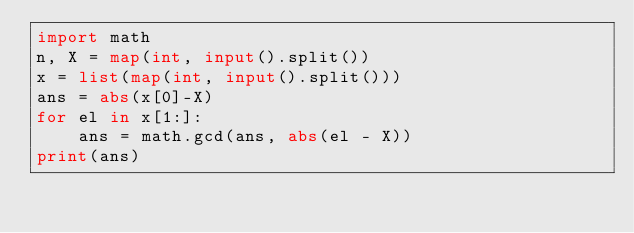<code> <loc_0><loc_0><loc_500><loc_500><_Python_>import math
n, X = map(int, input().split())
x = list(map(int, input().split()))
ans = abs(x[0]-X)
for el in x[1:]:
    ans = math.gcd(ans, abs(el - X))
print(ans)</code> 